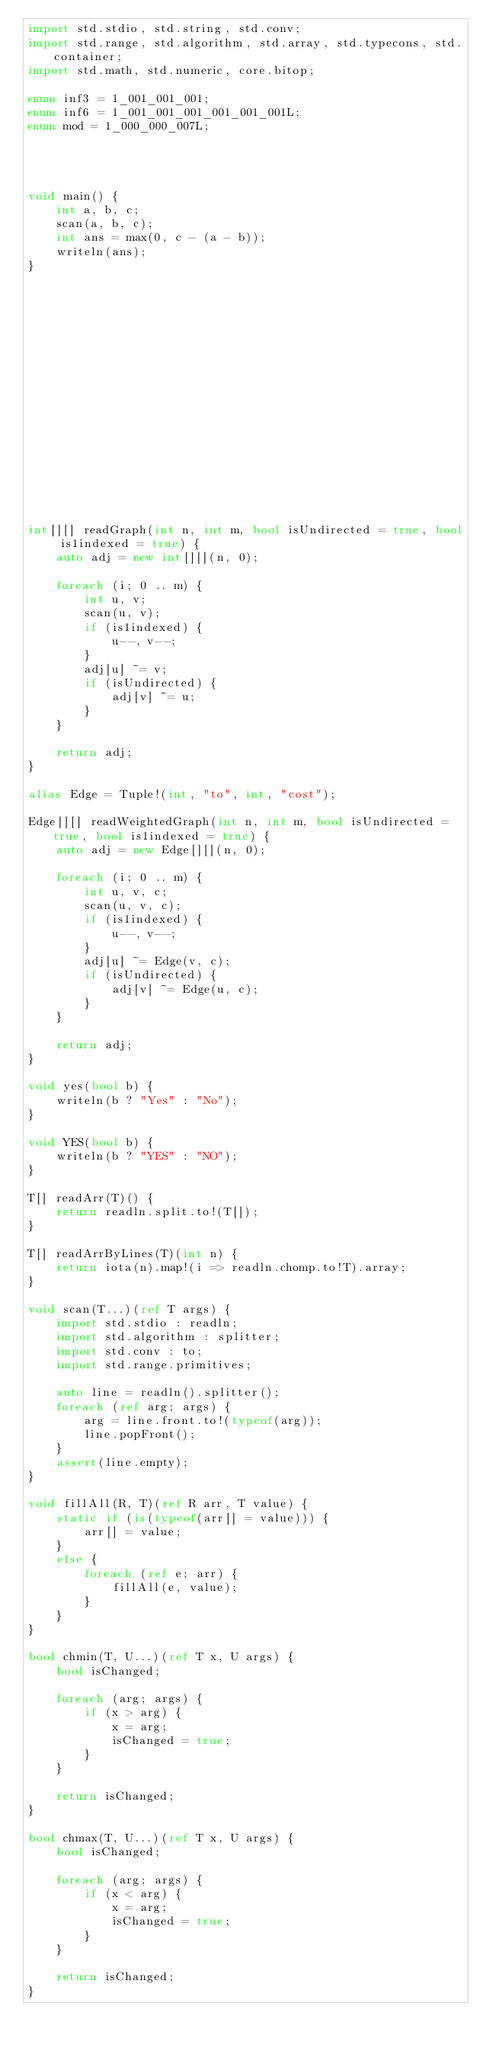Convert code to text. <code><loc_0><loc_0><loc_500><loc_500><_D_>import std.stdio, std.string, std.conv;
import std.range, std.algorithm, std.array, std.typecons, std.container;
import std.math, std.numeric, core.bitop;

enum inf3 = 1_001_001_001;
enum inf6 = 1_001_001_001_001_001_001L;
enum mod = 1_000_000_007L;




void main() {
    int a, b, c;
    scan(a, b, c);
    int ans = max(0, c - (a - b));
    writeln(ans);
}


















int[][] readGraph(int n, int m, bool isUndirected = true, bool is1indexed = true) {
    auto adj = new int[][](n, 0);

    foreach (i; 0 .. m) {
        int u, v;
        scan(u, v);
        if (is1indexed) {
            u--, v--;
        }
        adj[u] ~= v;
        if (isUndirected) {
            adj[v] ~= u;
        }
    }

    return adj;
}

alias Edge = Tuple!(int, "to", int, "cost");

Edge[][] readWeightedGraph(int n, int m, bool isUndirected = true, bool is1indexed = true) {
    auto adj = new Edge[][](n, 0);

    foreach (i; 0 .. m) {
        int u, v, c;
        scan(u, v, c);
        if (is1indexed) {
            u--, v--;
        }
        adj[u] ~= Edge(v, c);
        if (isUndirected) {
            adj[v] ~= Edge(u, c);
        }
    }

    return adj;
}

void yes(bool b) {
    writeln(b ? "Yes" : "No");
}

void YES(bool b) {
    writeln(b ? "YES" : "NO");
}

T[] readArr(T)() {
    return readln.split.to!(T[]);
}

T[] readArrByLines(T)(int n) {
    return iota(n).map!(i => readln.chomp.to!T).array;
}

void scan(T...)(ref T args) {
    import std.stdio : readln;
    import std.algorithm : splitter;
    import std.conv : to;
    import std.range.primitives;

    auto line = readln().splitter();
    foreach (ref arg; args) {
        arg = line.front.to!(typeof(arg));
        line.popFront();
    }
    assert(line.empty);
}

void fillAll(R, T)(ref R arr, T value) {
    static if (is(typeof(arr[] = value))) {
        arr[] = value;
    }
    else {
        foreach (ref e; arr) {
            fillAll(e, value);
        }
    }
}

bool chmin(T, U...)(ref T x, U args) {
    bool isChanged;

    foreach (arg; args) {
        if (x > arg) {
            x = arg;
            isChanged = true;
        }
    }

    return isChanged;
}

bool chmax(T, U...)(ref T x, U args) {
    bool isChanged;

    foreach (arg; args) {
        if (x < arg) {
            x = arg;
            isChanged = true;
        }
    }

    return isChanged;
}
</code> 